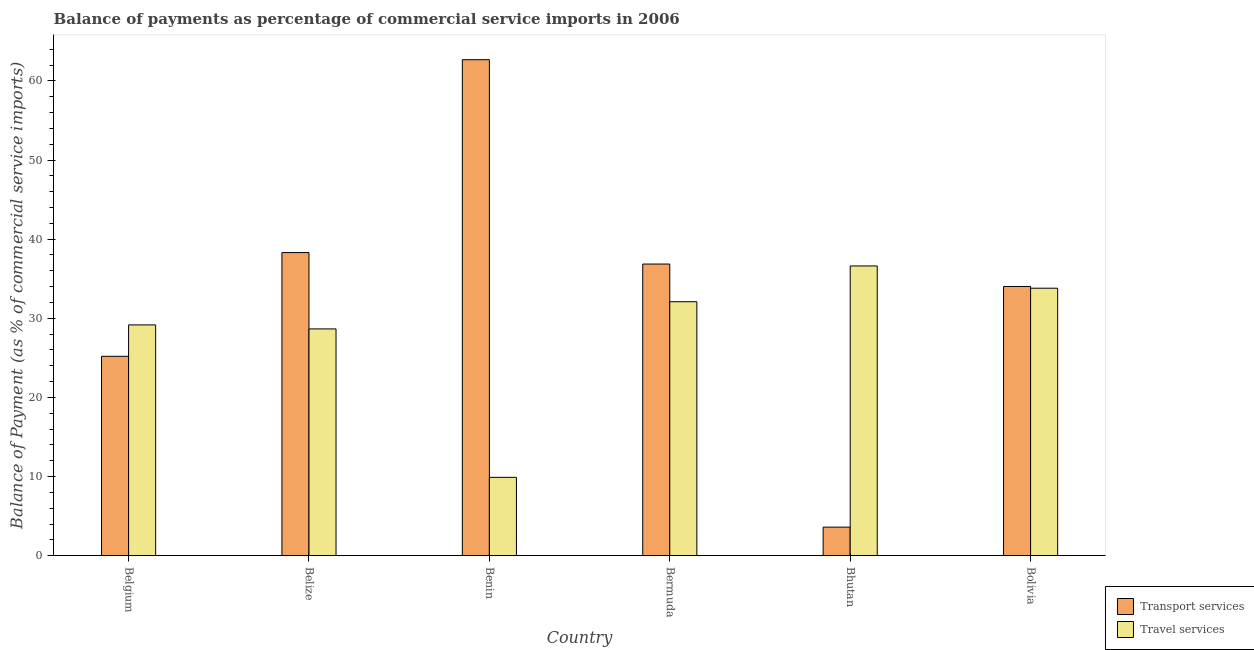How many groups of bars are there?
Make the answer very short. 6. Are the number of bars per tick equal to the number of legend labels?
Give a very brief answer. Yes. Are the number of bars on each tick of the X-axis equal?
Your answer should be very brief. Yes. How many bars are there on the 1st tick from the left?
Keep it short and to the point. 2. How many bars are there on the 6th tick from the right?
Ensure brevity in your answer.  2. What is the label of the 4th group of bars from the left?
Provide a succinct answer. Bermuda. What is the balance of payments of transport services in Belgium?
Offer a terse response. 25.19. Across all countries, what is the maximum balance of payments of transport services?
Give a very brief answer. 62.68. Across all countries, what is the minimum balance of payments of transport services?
Provide a short and direct response. 3.6. In which country was the balance of payments of travel services maximum?
Your response must be concise. Bhutan. In which country was the balance of payments of travel services minimum?
Your answer should be very brief. Benin. What is the total balance of payments of transport services in the graph?
Your response must be concise. 200.65. What is the difference between the balance of payments of transport services in Benin and that in Bhutan?
Keep it short and to the point. 59.08. What is the difference between the balance of payments of transport services in Benin and the balance of payments of travel services in Bhutan?
Your response must be concise. 26.07. What is the average balance of payments of travel services per country?
Your answer should be very brief. 28.37. What is the difference between the balance of payments of travel services and balance of payments of transport services in Benin?
Provide a short and direct response. -52.78. What is the ratio of the balance of payments of travel services in Belgium to that in Bolivia?
Ensure brevity in your answer.  0.86. Is the balance of payments of transport services in Belgium less than that in Benin?
Keep it short and to the point. Yes. Is the difference between the balance of payments of transport services in Bermuda and Bolivia greater than the difference between the balance of payments of travel services in Bermuda and Bolivia?
Provide a short and direct response. Yes. What is the difference between the highest and the second highest balance of payments of travel services?
Ensure brevity in your answer.  2.81. What is the difference between the highest and the lowest balance of payments of transport services?
Ensure brevity in your answer.  59.08. In how many countries, is the balance of payments of transport services greater than the average balance of payments of transport services taken over all countries?
Your answer should be very brief. 4. What does the 1st bar from the left in Bermuda represents?
Ensure brevity in your answer.  Transport services. What does the 2nd bar from the right in Belize represents?
Your answer should be compact. Transport services. How many bars are there?
Ensure brevity in your answer.  12. Are all the bars in the graph horizontal?
Make the answer very short. No. What is the difference between two consecutive major ticks on the Y-axis?
Make the answer very short. 10. How are the legend labels stacked?
Ensure brevity in your answer.  Vertical. What is the title of the graph?
Offer a very short reply. Balance of payments as percentage of commercial service imports in 2006. Does "Non-solid fuel" appear as one of the legend labels in the graph?
Your answer should be compact. No. What is the label or title of the X-axis?
Offer a very short reply. Country. What is the label or title of the Y-axis?
Your response must be concise. Balance of Payment (as % of commercial service imports). What is the Balance of Payment (as % of commercial service imports) in Transport services in Belgium?
Give a very brief answer. 25.19. What is the Balance of Payment (as % of commercial service imports) in Travel services in Belgium?
Offer a very short reply. 29.16. What is the Balance of Payment (as % of commercial service imports) in Transport services in Belize?
Offer a very short reply. 38.3. What is the Balance of Payment (as % of commercial service imports) in Travel services in Belize?
Provide a short and direct response. 28.66. What is the Balance of Payment (as % of commercial service imports) in Transport services in Benin?
Ensure brevity in your answer.  62.68. What is the Balance of Payment (as % of commercial service imports) of Travel services in Benin?
Your response must be concise. 9.9. What is the Balance of Payment (as % of commercial service imports) of Transport services in Bermuda?
Make the answer very short. 36.85. What is the Balance of Payment (as % of commercial service imports) of Travel services in Bermuda?
Offer a very short reply. 32.09. What is the Balance of Payment (as % of commercial service imports) of Transport services in Bhutan?
Offer a terse response. 3.6. What is the Balance of Payment (as % of commercial service imports) of Travel services in Bhutan?
Provide a succinct answer. 36.61. What is the Balance of Payment (as % of commercial service imports) of Transport services in Bolivia?
Make the answer very short. 34.02. What is the Balance of Payment (as % of commercial service imports) in Travel services in Bolivia?
Your answer should be very brief. 33.8. Across all countries, what is the maximum Balance of Payment (as % of commercial service imports) of Transport services?
Make the answer very short. 62.68. Across all countries, what is the maximum Balance of Payment (as % of commercial service imports) of Travel services?
Your response must be concise. 36.61. Across all countries, what is the minimum Balance of Payment (as % of commercial service imports) in Transport services?
Give a very brief answer. 3.6. Across all countries, what is the minimum Balance of Payment (as % of commercial service imports) of Travel services?
Provide a short and direct response. 9.9. What is the total Balance of Payment (as % of commercial service imports) of Transport services in the graph?
Provide a short and direct response. 200.65. What is the total Balance of Payment (as % of commercial service imports) in Travel services in the graph?
Give a very brief answer. 170.21. What is the difference between the Balance of Payment (as % of commercial service imports) in Transport services in Belgium and that in Belize?
Provide a short and direct response. -13.11. What is the difference between the Balance of Payment (as % of commercial service imports) in Travel services in Belgium and that in Belize?
Your answer should be compact. 0.51. What is the difference between the Balance of Payment (as % of commercial service imports) in Transport services in Belgium and that in Benin?
Offer a terse response. -37.49. What is the difference between the Balance of Payment (as % of commercial service imports) in Travel services in Belgium and that in Benin?
Give a very brief answer. 19.27. What is the difference between the Balance of Payment (as % of commercial service imports) of Transport services in Belgium and that in Bermuda?
Offer a terse response. -11.66. What is the difference between the Balance of Payment (as % of commercial service imports) in Travel services in Belgium and that in Bermuda?
Provide a succinct answer. -2.93. What is the difference between the Balance of Payment (as % of commercial service imports) in Transport services in Belgium and that in Bhutan?
Your answer should be compact. 21.59. What is the difference between the Balance of Payment (as % of commercial service imports) in Travel services in Belgium and that in Bhutan?
Make the answer very short. -7.45. What is the difference between the Balance of Payment (as % of commercial service imports) of Transport services in Belgium and that in Bolivia?
Provide a succinct answer. -8.82. What is the difference between the Balance of Payment (as % of commercial service imports) of Travel services in Belgium and that in Bolivia?
Provide a succinct answer. -4.64. What is the difference between the Balance of Payment (as % of commercial service imports) of Transport services in Belize and that in Benin?
Your response must be concise. -24.38. What is the difference between the Balance of Payment (as % of commercial service imports) of Travel services in Belize and that in Benin?
Your response must be concise. 18.76. What is the difference between the Balance of Payment (as % of commercial service imports) of Transport services in Belize and that in Bermuda?
Your answer should be very brief. 1.45. What is the difference between the Balance of Payment (as % of commercial service imports) in Travel services in Belize and that in Bermuda?
Ensure brevity in your answer.  -3.44. What is the difference between the Balance of Payment (as % of commercial service imports) of Transport services in Belize and that in Bhutan?
Your response must be concise. 34.7. What is the difference between the Balance of Payment (as % of commercial service imports) in Travel services in Belize and that in Bhutan?
Your response must be concise. -7.96. What is the difference between the Balance of Payment (as % of commercial service imports) in Transport services in Belize and that in Bolivia?
Offer a very short reply. 4.28. What is the difference between the Balance of Payment (as % of commercial service imports) in Travel services in Belize and that in Bolivia?
Your answer should be very brief. -5.14. What is the difference between the Balance of Payment (as % of commercial service imports) in Transport services in Benin and that in Bermuda?
Your response must be concise. 25.83. What is the difference between the Balance of Payment (as % of commercial service imports) in Travel services in Benin and that in Bermuda?
Your response must be concise. -22.2. What is the difference between the Balance of Payment (as % of commercial service imports) in Transport services in Benin and that in Bhutan?
Provide a short and direct response. 59.08. What is the difference between the Balance of Payment (as % of commercial service imports) of Travel services in Benin and that in Bhutan?
Your answer should be compact. -26.72. What is the difference between the Balance of Payment (as % of commercial service imports) of Transport services in Benin and that in Bolivia?
Offer a very short reply. 28.66. What is the difference between the Balance of Payment (as % of commercial service imports) of Travel services in Benin and that in Bolivia?
Offer a terse response. -23.9. What is the difference between the Balance of Payment (as % of commercial service imports) in Transport services in Bermuda and that in Bhutan?
Your answer should be very brief. 33.25. What is the difference between the Balance of Payment (as % of commercial service imports) of Travel services in Bermuda and that in Bhutan?
Make the answer very short. -4.52. What is the difference between the Balance of Payment (as % of commercial service imports) in Transport services in Bermuda and that in Bolivia?
Make the answer very short. 2.84. What is the difference between the Balance of Payment (as % of commercial service imports) of Travel services in Bermuda and that in Bolivia?
Make the answer very short. -1.71. What is the difference between the Balance of Payment (as % of commercial service imports) in Transport services in Bhutan and that in Bolivia?
Offer a terse response. -30.41. What is the difference between the Balance of Payment (as % of commercial service imports) of Travel services in Bhutan and that in Bolivia?
Ensure brevity in your answer.  2.81. What is the difference between the Balance of Payment (as % of commercial service imports) of Transport services in Belgium and the Balance of Payment (as % of commercial service imports) of Travel services in Belize?
Provide a short and direct response. -3.46. What is the difference between the Balance of Payment (as % of commercial service imports) of Transport services in Belgium and the Balance of Payment (as % of commercial service imports) of Travel services in Benin?
Your answer should be compact. 15.3. What is the difference between the Balance of Payment (as % of commercial service imports) in Transport services in Belgium and the Balance of Payment (as % of commercial service imports) in Travel services in Bermuda?
Make the answer very short. -6.9. What is the difference between the Balance of Payment (as % of commercial service imports) of Transport services in Belgium and the Balance of Payment (as % of commercial service imports) of Travel services in Bhutan?
Keep it short and to the point. -11.42. What is the difference between the Balance of Payment (as % of commercial service imports) of Transport services in Belgium and the Balance of Payment (as % of commercial service imports) of Travel services in Bolivia?
Your answer should be very brief. -8.6. What is the difference between the Balance of Payment (as % of commercial service imports) of Transport services in Belize and the Balance of Payment (as % of commercial service imports) of Travel services in Benin?
Give a very brief answer. 28.41. What is the difference between the Balance of Payment (as % of commercial service imports) of Transport services in Belize and the Balance of Payment (as % of commercial service imports) of Travel services in Bermuda?
Offer a very short reply. 6.21. What is the difference between the Balance of Payment (as % of commercial service imports) in Transport services in Belize and the Balance of Payment (as % of commercial service imports) in Travel services in Bhutan?
Make the answer very short. 1.69. What is the difference between the Balance of Payment (as % of commercial service imports) of Transport services in Belize and the Balance of Payment (as % of commercial service imports) of Travel services in Bolivia?
Your answer should be very brief. 4.5. What is the difference between the Balance of Payment (as % of commercial service imports) in Transport services in Benin and the Balance of Payment (as % of commercial service imports) in Travel services in Bermuda?
Offer a very short reply. 30.59. What is the difference between the Balance of Payment (as % of commercial service imports) in Transport services in Benin and the Balance of Payment (as % of commercial service imports) in Travel services in Bhutan?
Ensure brevity in your answer.  26.07. What is the difference between the Balance of Payment (as % of commercial service imports) in Transport services in Benin and the Balance of Payment (as % of commercial service imports) in Travel services in Bolivia?
Offer a terse response. 28.88. What is the difference between the Balance of Payment (as % of commercial service imports) in Transport services in Bermuda and the Balance of Payment (as % of commercial service imports) in Travel services in Bhutan?
Provide a short and direct response. 0.24. What is the difference between the Balance of Payment (as % of commercial service imports) in Transport services in Bermuda and the Balance of Payment (as % of commercial service imports) in Travel services in Bolivia?
Keep it short and to the point. 3.06. What is the difference between the Balance of Payment (as % of commercial service imports) of Transport services in Bhutan and the Balance of Payment (as % of commercial service imports) of Travel services in Bolivia?
Keep it short and to the point. -30.19. What is the average Balance of Payment (as % of commercial service imports) in Transport services per country?
Keep it short and to the point. 33.44. What is the average Balance of Payment (as % of commercial service imports) in Travel services per country?
Your response must be concise. 28.37. What is the difference between the Balance of Payment (as % of commercial service imports) of Transport services and Balance of Payment (as % of commercial service imports) of Travel services in Belgium?
Provide a short and direct response. -3.97. What is the difference between the Balance of Payment (as % of commercial service imports) of Transport services and Balance of Payment (as % of commercial service imports) of Travel services in Belize?
Your answer should be very brief. 9.65. What is the difference between the Balance of Payment (as % of commercial service imports) in Transport services and Balance of Payment (as % of commercial service imports) in Travel services in Benin?
Your response must be concise. 52.78. What is the difference between the Balance of Payment (as % of commercial service imports) in Transport services and Balance of Payment (as % of commercial service imports) in Travel services in Bermuda?
Your answer should be compact. 4.76. What is the difference between the Balance of Payment (as % of commercial service imports) in Transport services and Balance of Payment (as % of commercial service imports) in Travel services in Bhutan?
Ensure brevity in your answer.  -33.01. What is the difference between the Balance of Payment (as % of commercial service imports) of Transport services and Balance of Payment (as % of commercial service imports) of Travel services in Bolivia?
Provide a succinct answer. 0.22. What is the ratio of the Balance of Payment (as % of commercial service imports) in Transport services in Belgium to that in Belize?
Your response must be concise. 0.66. What is the ratio of the Balance of Payment (as % of commercial service imports) in Travel services in Belgium to that in Belize?
Give a very brief answer. 1.02. What is the ratio of the Balance of Payment (as % of commercial service imports) in Transport services in Belgium to that in Benin?
Your answer should be compact. 0.4. What is the ratio of the Balance of Payment (as % of commercial service imports) in Travel services in Belgium to that in Benin?
Your response must be concise. 2.95. What is the ratio of the Balance of Payment (as % of commercial service imports) in Transport services in Belgium to that in Bermuda?
Make the answer very short. 0.68. What is the ratio of the Balance of Payment (as % of commercial service imports) of Travel services in Belgium to that in Bermuda?
Provide a succinct answer. 0.91. What is the ratio of the Balance of Payment (as % of commercial service imports) in Transport services in Belgium to that in Bhutan?
Your answer should be compact. 6.99. What is the ratio of the Balance of Payment (as % of commercial service imports) of Travel services in Belgium to that in Bhutan?
Keep it short and to the point. 0.8. What is the ratio of the Balance of Payment (as % of commercial service imports) in Transport services in Belgium to that in Bolivia?
Keep it short and to the point. 0.74. What is the ratio of the Balance of Payment (as % of commercial service imports) of Travel services in Belgium to that in Bolivia?
Offer a terse response. 0.86. What is the ratio of the Balance of Payment (as % of commercial service imports) of Transport services in Belize to that in Benin?
Make the answer very short. 0.61. What is the ratio of the Balance of Payment (as % of commercial service imports) of Travel services in Belize to that in Benin?
Your answer should be compact. 2.9. What is the ratio of the Balance of Payment (as % of commercial service imports) of Transport services in Belize to that in Bermuda?
Offer a terse response. 1.04. What is the ratio of the Balance of Payment (as % of commercial service imports) of Travel services in Belize to that in Bermuda?
Your answer should be very brief. 0.89. What is the ratio of the Balance of Payment (as % of commercial service imports) of Transport services in Belize to that in Bhutan?
Offer a terse response. 10.63. What is the ratio of the Balance of Payment (as % of commercial service imports) of Travel services in Belize to that in Bhutan?
Your response must be concise. 0.78. What is the ratio of the Balance of Payment (as % of commercial service imports) in Transport services in Belize to that in Bolivia?
Your answer should be compact. 1.13. What is the ratio of the Balance of Payment (as % of commercial service imports) in Travel services in Belize to that in Bolivia?
Your answer should be compact. 0.85. What is the ratio of the Balance of Payment (as % of commercial service imports) of Transport services in Benin to that in Bermuda?
Provide a succinct answer. 1.7. What is the ratio of the Balance of Payment (as % of commercial service imports) of Travel services in Benin to that in Bermuda?
Your response must be concise. 0.31. What is the ratio of the Balance of Payment (as % of commercial service imports) of Transport services in Benin to that in Bhutan?
Offer a very short reply. 17.39. What is the ratio of the Balance of Payment (as % of commercial service imports) in Travel services in Benin to that in Bhutan?
Offer a terse response. 0.27. What is the ratio of the Balance of Payment (as % of commercial service imports) in Transport services in Benin to that in Bolivia?
Provide a short and direct response. 1.84. What is the ratio of the Balance of Payment (as % of commercial service imports) in Travel services in Benin to that in Bolivia?
Make the answer very short. 0.29. What is the ratio of the Balance of Payment (as % of commercial service imports) in Transport services in Bermuda to that in Bhutan?
Ensure brevity in your answer.  10.23. What is the ratio of the Balance of Payment (as % of commercial service imports) in Travel services in Bermuda to that in Bhutan?
Your answer should be very brief. 0.88. What is the ratio of the Balance of Payment (as % of commercial service imports) in Transport services in Bermuda to that in Bolivia?
Provide a succinct answer. 1.08. What is the ratio of the Balance of Payment (as % of commercial service imports) in Travel services in Bermuda to that in Bolivia?
Provide a short and direct response. 0.95. What is the ratio of the Balance of Payment (as % of commercial service imports) in Transport services in Bhutan to that in Bolivia?
Offer a very short reply. 0.11. What is the ratio of the Balance of Payment (as % of commercial service imports) in Travel services in Bhutan to that in Bolivia?
Provide a short and direct response. 1.08. What is the difference between the highest and the second highest Balance of Payment (as % of commercial service imports) in Transport services?
Your answer should be compact. 24.38. What is the difference between the highest and the second highest Balance of Payment (as % of commercial service imports) of Travel services?
Offer a terse response. 2.81. What is the difference between the highest and the lowest Balance of Payment (as % of commercial service imports) of Transport services?
Give a very brief answer. 59.08. What is the difference between the highest and the lowest Balance of Payment (as % of commercial service imports) of Travel services?
Keep it short and to the point. 26.72. 